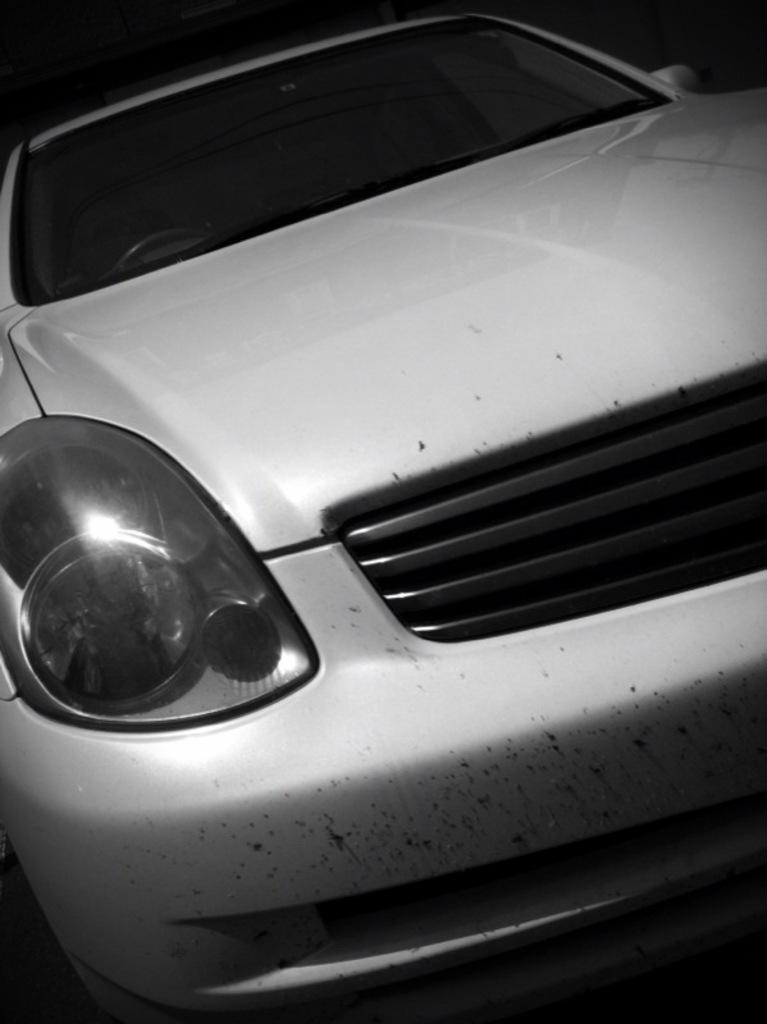Please provide a concise description of this image. In the center of the image a car is present. 